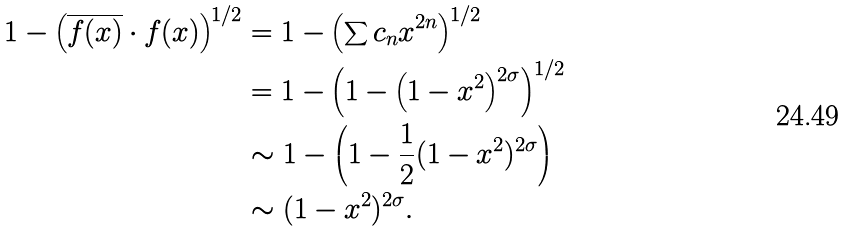<formula> <loc_0><loc_0><loc_500><loc_500>1 - \left ( \overline { f ( x ) } \cdot f ( x ) \right ) ^ { 1 / 2 } & = 1 - \left ( \sum c _ { n } x ^ { 2 n } \right ) ^ { 1 / 2 } \\ & = 1 - \left ( 1 - \left ( 1 - x ^ { 2 } \right ) ^ { 2 \sigma } \right ) ^ { 1 / 2 } \\ & \sim 1 - \left ( 1 - \frac { 1 } { 2 } ( 1 - x ^ { 2 } ) ^ { 2 \sigma } \right ) \\ & \sim ( 1 - x ^ { 2 } ) ^ { 2 \sigma } .</formula> 